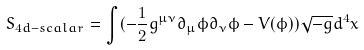Convert formula to latex. <formula><loc_0><loc_0><loc_500><loc_500>S _ { 4 d - s c a l a r } = \int ( - \frac { 1 } { 2 } g ^ { \mu \nu } \partial _ { \mu } \phi \partial _ { \nu } \phi - V ( \phi ) ) \sqrt { - g } d ^ { 4 } x</formula> 